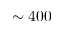Convert formula to latex. <formula><loc_0><loc_0><loc_500><loc_500>\sim 4 0 0</formula> 